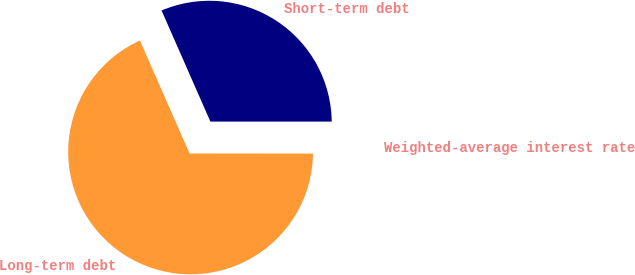<chart> <loc_0><loc_0><loc_500><loc_500><pie_chart><fcel>Short-term debt<fcel>Long-term debt<fcel>Weighted-average interest rate<nl><fcel>31.59%<fcel>68.4%<fcel>0.01%<nl></chart> 